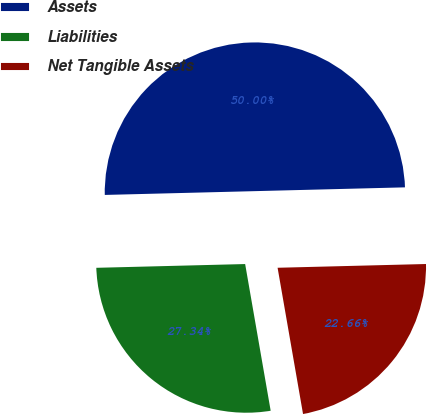Convert chart. <chart><loc_0><loc_0><loc_500><loc_500><pie_chart><fcel>Assets<fcel>Liabilities<fcel>Net Tangible Assets<nl><fcel>50.0%<fcel>27.34%<fcel>22.66%<nl></chart> 